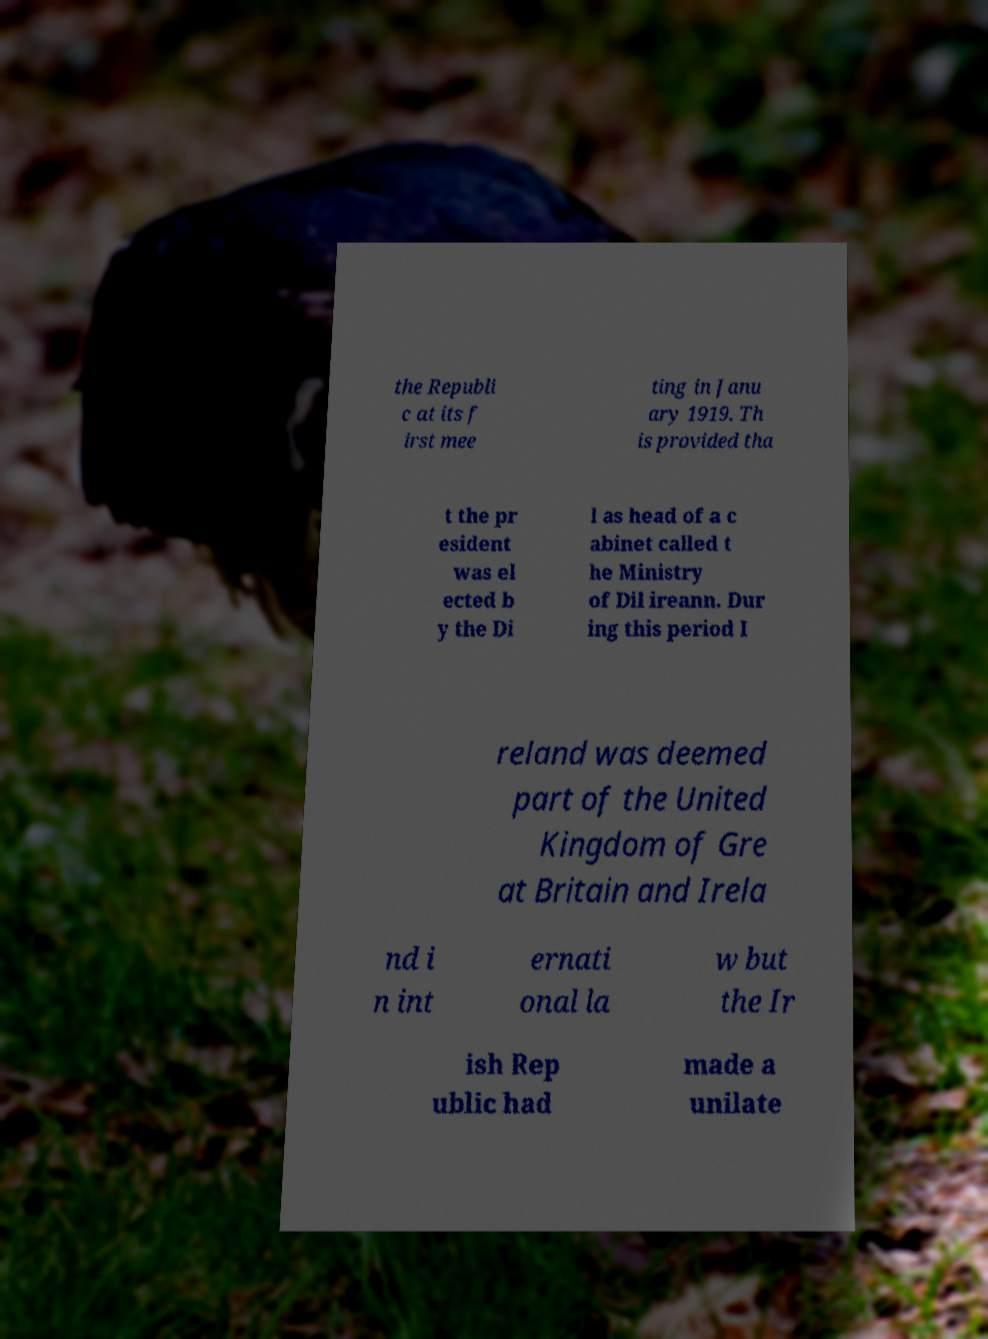Please identify and transcribe the text found in this image. the Republi c at its f irst mee ting in Janu ary 1919. Th is provided tha t the pr esident was el ected b y the Di l as head of a c abinet called t he Ministry of Dil ireann. Dur ing this period I reland was deemed part of the United Kingdom of Gre at Britain and Irela nd i n int ernati onal la w but the Ir ish Rep ublic had made a unilate 